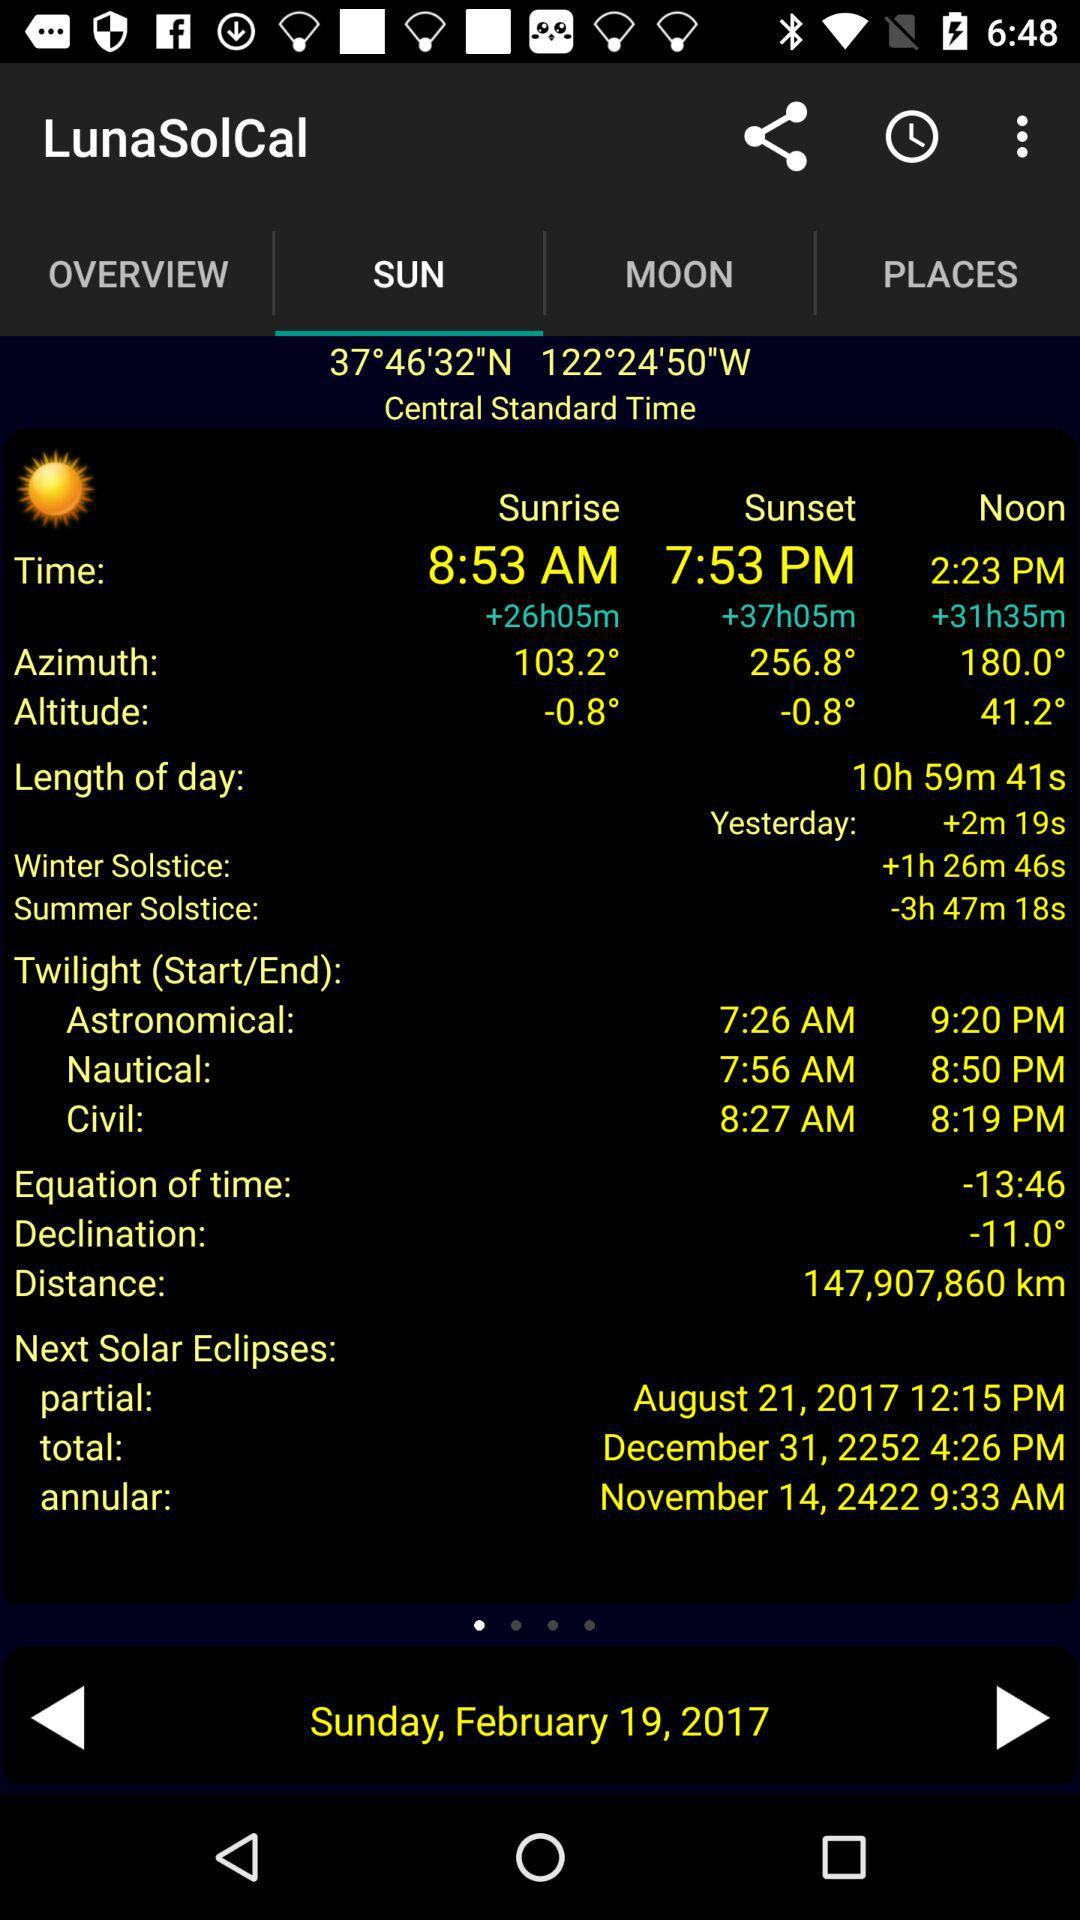What is the azimuth for sunrise? The azimuth for sunrise is 103.2°. 